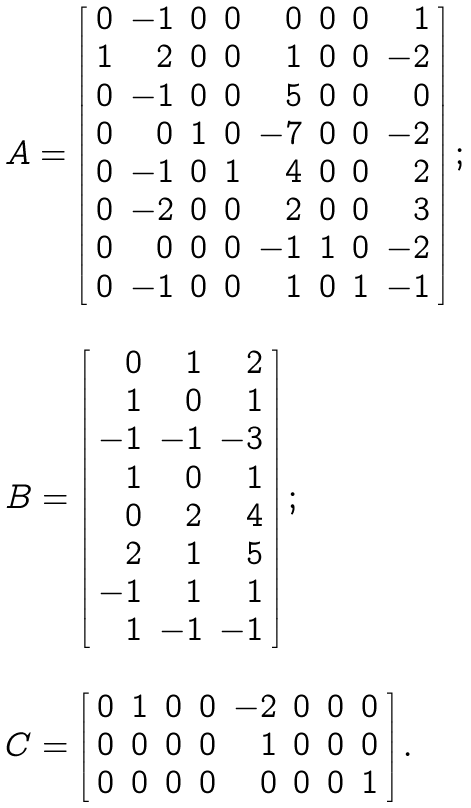<formula> <loc_0><loc_0><loc_500><loc_500>\begin{array} { l } A = \left [ \begin{array} { r r r r r r r r } 0 & - 1 & 0 & 0 & 0 & 0 & 0 & 1 \\ 1 & 2 & 0 & 0 & 1 & 0 & 0 & - 2 \\ 0 & - 1 & 0 & 0 & 5 & 0 & 0 & 0 \\ 0 & 0 & 1 & 0 & - 7 & 0 & 0 & - 2 \\ 0 & - 1 & 0 & 1 & 4 & 0 & 0 & 2 \\ 0 & - 2 & 0 & 0 & 2 & 0 & 0 & 3 \\ 0 & 0 & 0 & 0 & - 1 & 1 & 0 & - 2 \\ 0 & - 1 & 0 & 0 & 1 & 0 & 1 & - 1 \\ \end{array} \right ] ; \\ \\ B = \left [ \begin{array} { r r r } 0 & 1 & 2 \\ 1 & 0 & 1 \\ - 1 & - 1 & - 3 \\ 1 & 0 & 1 \\ 0 & 2 & 4 \\ 2 & 1 & 5 \\ - 1 & 1 & 1 \\ 1 & - 1 & - 1 \\ \end{array} \right ] ; \\ \\ C = \left [ \begin{array} { r r r r r r r r } 0 & 1 & 0 & 0 & - 2 & 0 & 0 & 0 \\ 0 & 0 & 0 & 0 & 1 & 0 & 0 & 0 \\ 0 & 0 & 0 & 0 & 0 & 0 & 0 & 1 \\ \end{array} \right ] . \\ \end{array}</formula> 